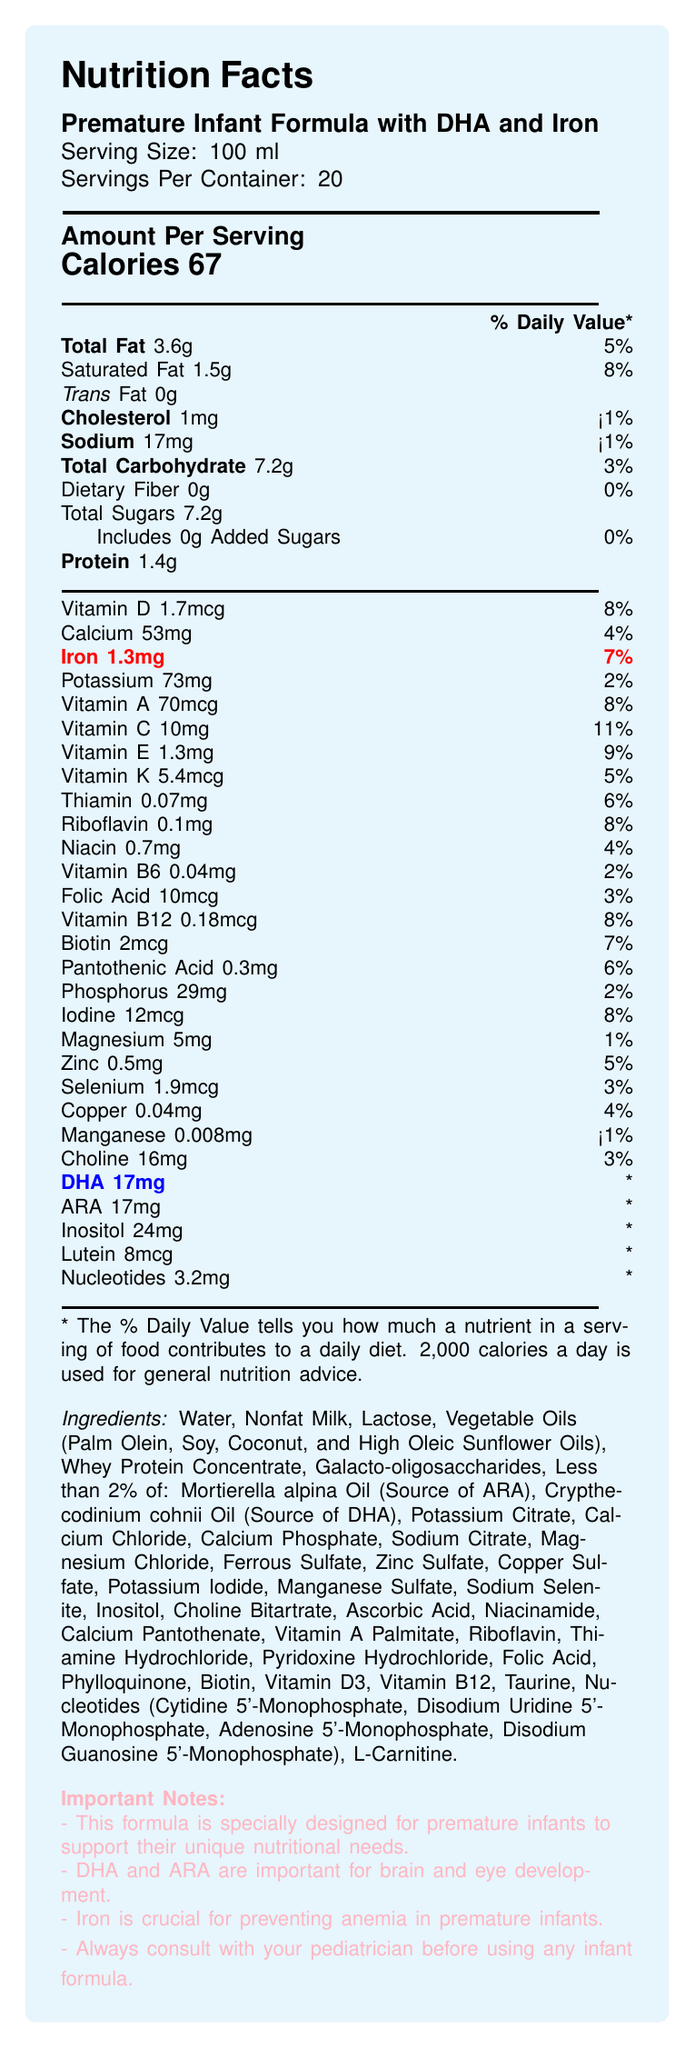what is the serving size? The document states that the serving size is 100 ml.
Answer: 100 ml how many calories are in one serving? The document indicates that one serving contains 67 calories.
Answer: 67 calories what is the amount of total fat per serving? The document shows that each serving contains 3.6 grams of total fat.
Answer: 3.6 g what percentage of the daily value for Vitamin C does one serving provide? The document states that one serving provides 11% of the daily value for Vitamin C.
Answer: 11% how much iron is in a serving, and what percentage of the daily value does it represent? According to the document, each serving contains 1.3 mg of iron, which represents 7% of the daily value.
Answer: 1.3 mg, 7% which of the following nutrients has the highest daily value percentage per serving?
A. Vitamin A
B. Vitamin C
C. Iron
D. Protein The daily values are: Vitamin A (8%), Vitamin C (11%), Iron (7%), and Protein (not listed as a percentage). Vitamin C has the highest daily value at 11%.
Answer: B. Vitamin C which ingredient is listed as a source of DHA in the formula?
A. Mortierella alpina Oil
B. Crypthecodinium cohnii Oil
C. Galacto-oligosaccharides
D. Sodium Citrate The document lists Crypthecodinium cohnii Oil as the source of DHA.
Answer: B. Crypthecodinium cohnii Oil true or false: This formula contains added sugars. The document indicates that the formula contains 0 grams of added sugars.
Answer: False summarize the main purpose of this document. The main idea of the document is to inform about the nutritional content, ingredients, and importance of a specialized infant formula designed for premature babies, highlighting its role in brain and eye development and anemia prevention.
Answer: The document provides the nutritional facts for a fortified premature infant formula with DHA and Iron, detailing the amount per serving, daily values of various nutrients, ingredients, and the importance of certain components like DHA, ARA, and Iron for premature infants. how much iodine is in one serving, and what is its daily value percentage? The document states that each serving contains 12 mcg of iodine, which is 8% of the daily value.
Answer: 12 mcg, 8% is Vitamin D content in this formula above or below 10 mcg per serving? The document indicates that the content of Vitamin D per serving is 1.7 mcg.
Answer: Below which items are indicated with an asterisk for having no established daily value? The document specifies that these items (DHA, ARA, Inositol, Lutein, Nucleotides) have asterisks noting that their daily values are not established.
Answer: DHA, ARA, Inositol, Lutein, Nucleotides why is iron included in the formula? The document highlights that iron is crucial for preventing anemia in premature infants.
Answer: To prevent anemia in premature infants how many servings are there per container? The document states that there are 20 servings per container.
Answer: 20 what is the amount of choline in one serving? The document indicates that each serving contains 16 mg of choline.
Answer: 16 mg how many nutrients listed have a daily value of less than 5%? The nutrients with daily values less than 5% are Magnesium (1%) and Manganese (<1%).
Answer: Two what is the contact information for customer service? The document does not provide any contact information for customer service.
Answer: Not enough information how does this formula support brain and eye development? The document states that DHA and ARA are important for brain and eye development.
Answer: Contains DHA and ARA which ingredient in the formula is less than 2%? The document mentions several ingredients that compose less than 2% of the formula.
Answer: Ingredients like Mortierella alpina Oil, Crypthecodinium cohnii Oil, Potassium Citrate, Calcium Chloride, etc., are listed as less than 2%. how much riboflavin is there in one serving? The document shows that each serving has 0.1 mg of riboflavin.
Answer: 0.1 mg 